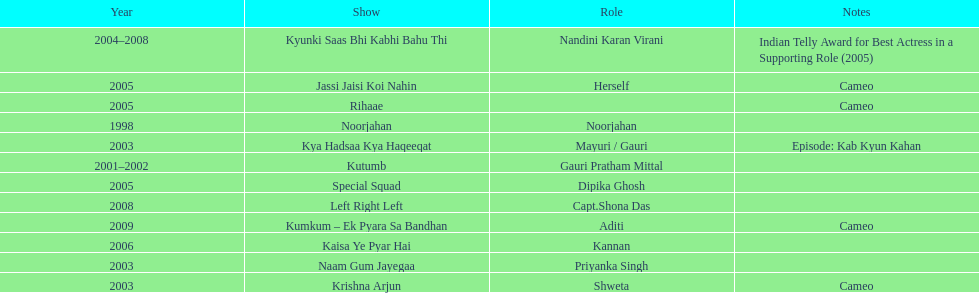How many shows were there in 2005? 3. 